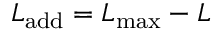<formula> <loc_0><loc_0><loc_500><loc_500>L _ { a d d } = L _ { \max } - L</formula> 